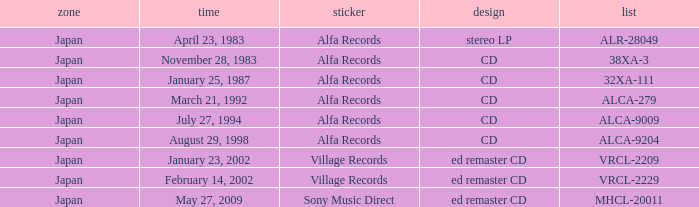Which date is in CD format? November 28, 1983, January 25, 1987, March 21, 1992, July 27, 1994, August 29, 1998. 